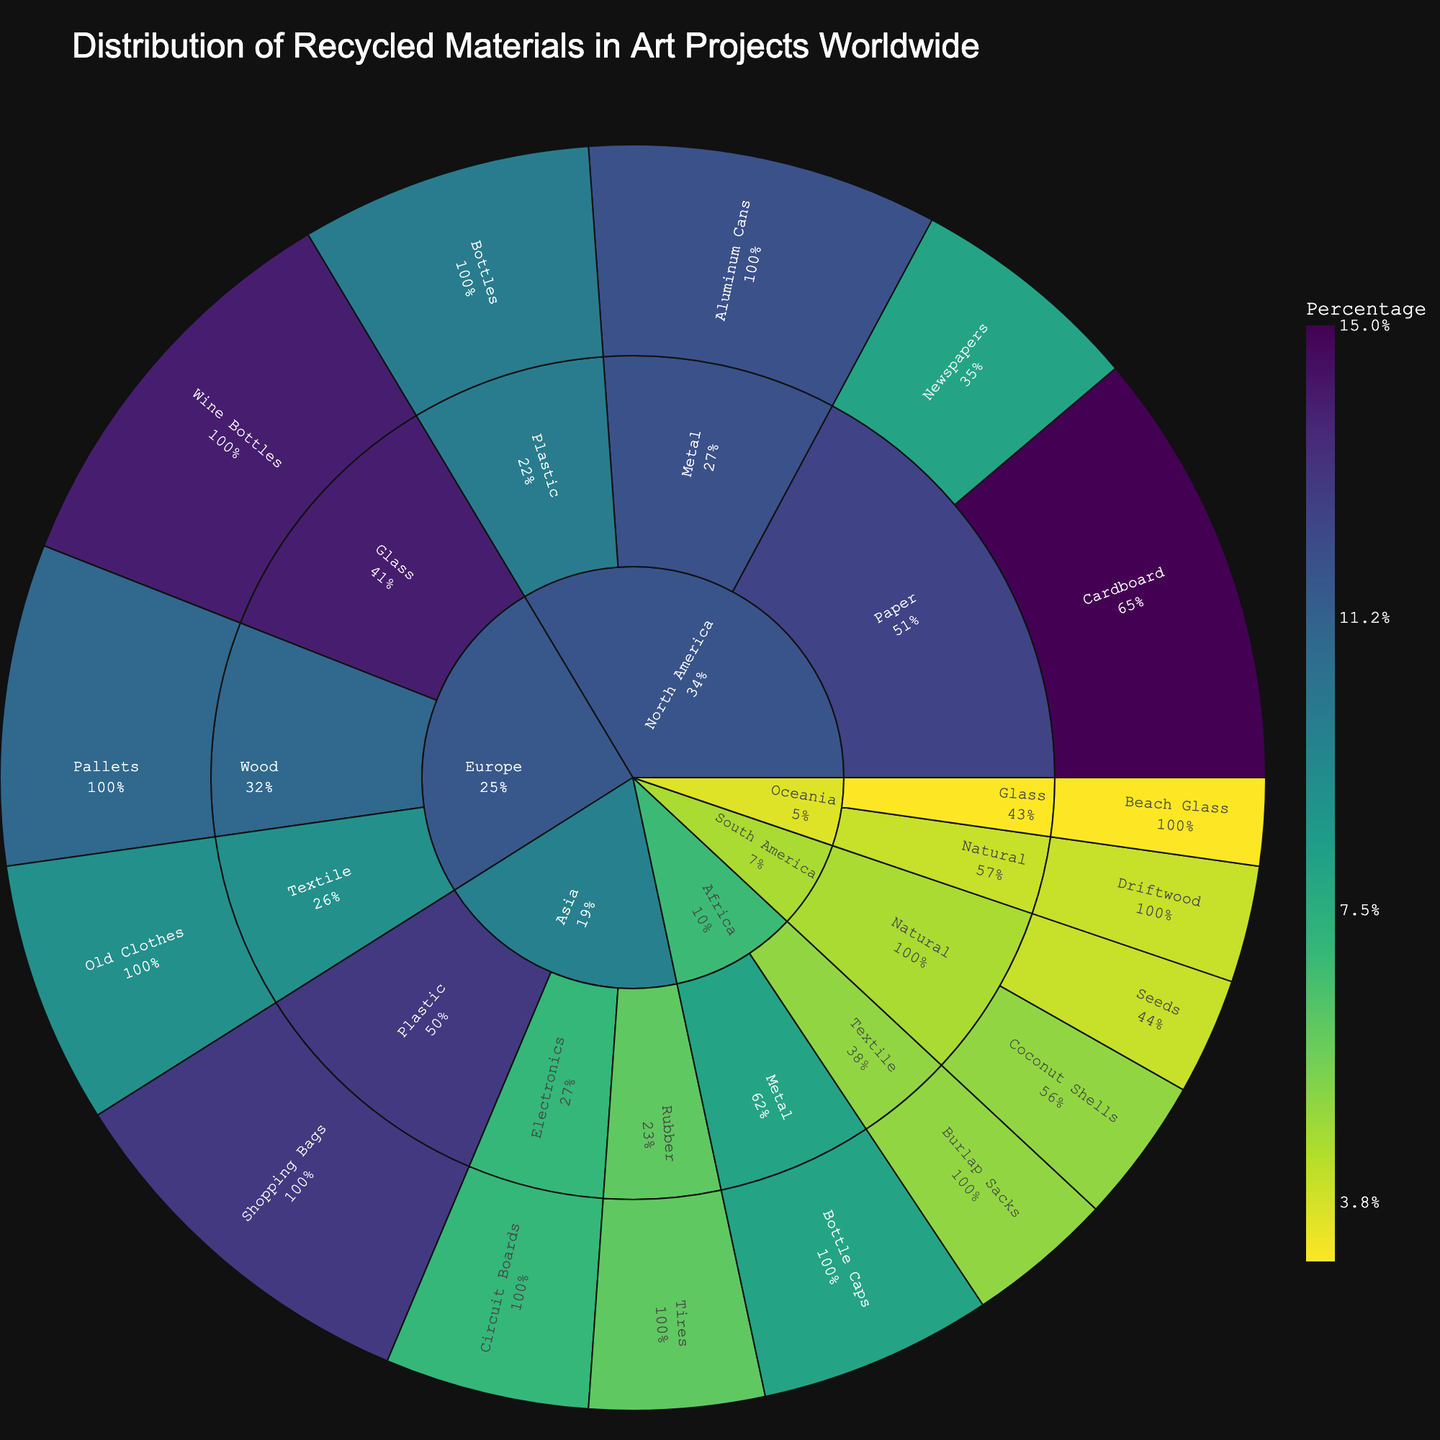what is the title of the plot? The title is typically displayed prominently at the top of the plot and summarizes what the plot is about. In this case, we can see it reads "Distribution of Recycled Materials in Art Projects Worldwide."
Answer: Distribution of Recycled Materials in Art Projects Worldwide Which region has the highest percentage of metal as recycled material? Identify all the regions that have metal as a main category and then compare their contributions. North America and Africa are the regions with metal. North America's metal contribution (Aluminum Cans) is 12%, while Africa's metal contribution (Bottle Caps) is 8%.
Answer: North America What is the most used specific material in Europe? Observe the inner rings of the sunburst specific to Europe to find the specific materials and their respective percentages. The materials for Europe include Wine Bottles (14%), Old Clothes (9%), and Pallets (11%). Wine Bottles have the highest percentage.
Answer: Wine Bottles How much greater is the usage of glass in Europe compared to Oceania? Identify the percentage values for glass in both Europe and Oceania. Europe uses 14% for Wine Bottles, and Oceania uses 3% for Beach Glass. Calculate the difference: 14% - 3% = 11%.
Answer: 11% Which specific material in Asia has the lowest percentage? Inspect the outermost ring in the Asia section for each specific material’s percentage values. Circuit Boards have 7%, Tires have 6%, and Shopping Bags have 13%, making Tires the lowest.
Answer: Tires What's the total percentage of natural materials in South America? Locate the specific materials under the natural materials category in the South America section. The values are Coconut Shells at 5% and Seeds at 4%. Add them together: 5% + 4% = 9%.
Answer: 9% What is the least used material and its region? Identify the smallest segment in the sunburst plot. Oceania uses Beach Glass, which is 3%. This is the smallest value in the dataset.
Answer: Beach Glass, Oceania How does the usage of textile in Europe compare to Africa? Find the segments under textile for both Europe and Africa. Europe has Old Clothes at 9%, and Africa has Burlap Sacks at 5%. Compare these values. 9% is greater than 5%.
Answer: Europe uses more textile What specific material has the highest percentage in North America? Look at all the specific material segments within North America's section of the sunburst plot. The specific materials are Cardboard (15%), Newspapers (8%), Aluminum Cans (12%), and Bottles (10%). The highest one is Cardboard at 15%.
Answer: Cardboard Which region has the most diversity in materials used? Determine the region with the largest number of different materials categories when examining the segments coming from the central region ring. Asia uses Plastic, Electronics, and Rubber. North America uses Paper, Metal, and Plastic. Europe uses Glass, Textile, and Wood. South America uses Natural. Africa uses Metal and Textile. Oceania uses Glass and Natural. Both Asia, North America, and Europe each use 3 materials, but since they have similar counts, selecting any of these regions is reasonable.
Answer: Asia, North America, or Europe 